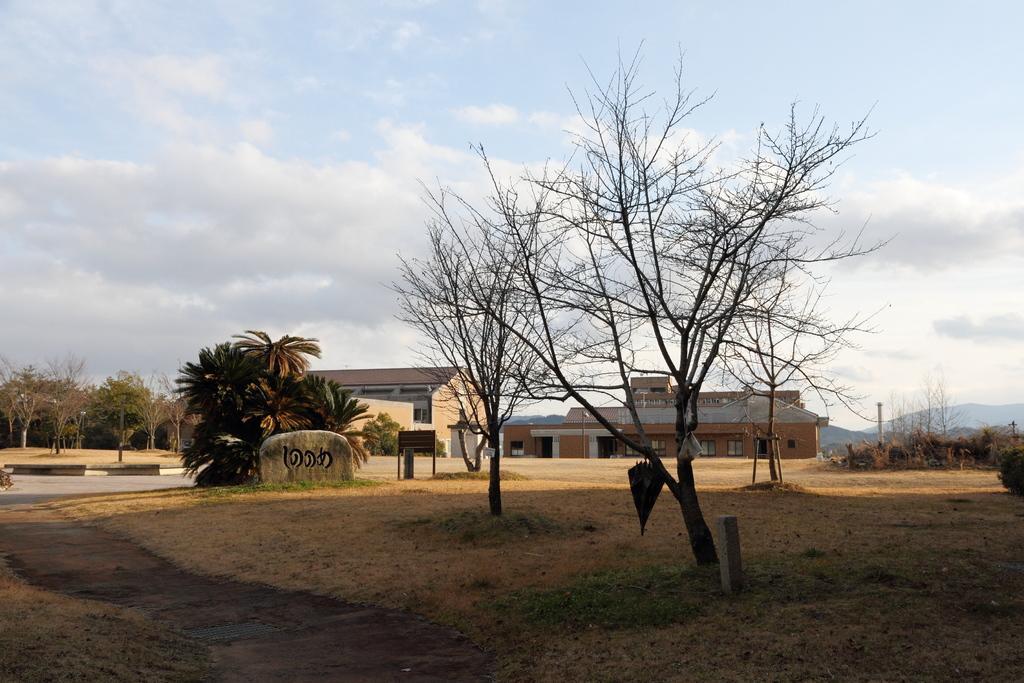Please provide a concise description of this image. At the bottom of the image I can see the grass. In the middle of the image I can see trees. In the background, I can see buildings and groups of trees. There are clouds in the sky. 